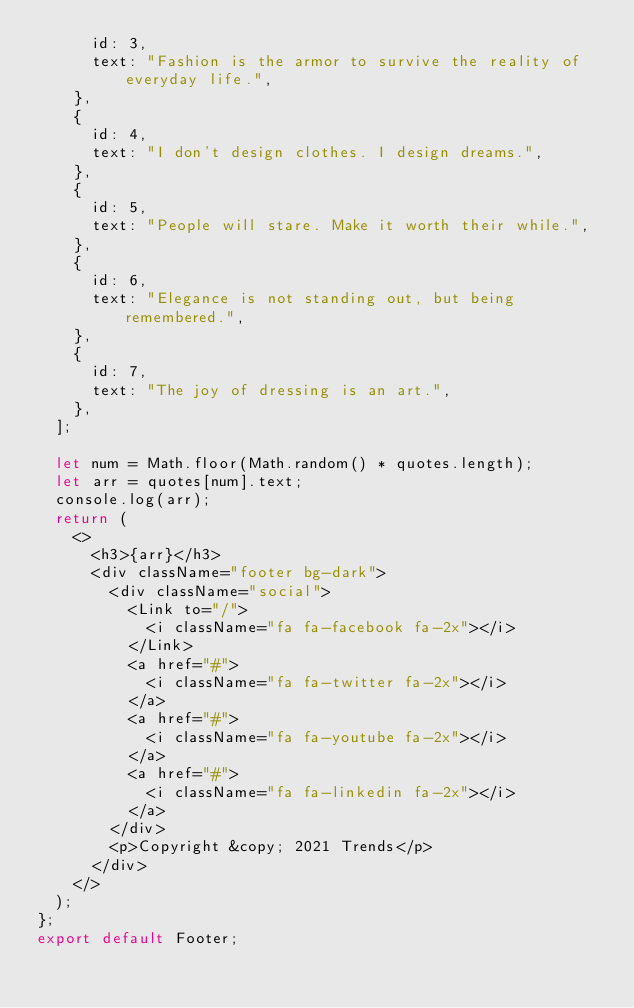<code> <loc_0><loc_0><loc_500><loc_500><_JavaScript_>      id: 3,
      text: "Fashion is the armor to survive the reality of everyday life.",
    },
    {
      id: 4,
      text: "I don't design clothes. I design dreams.",
    },
    {
      id: 5,
      text: "People will stare. Make it worth their while.",
    },
    {
      id: 6,
      text: "Elegance is not standing out, but being remembered.",
    },
    {
      id: 7,
      text: "The joy of dressing is an art.",
    },
  ];

  let num = Math.floor(Math.random() * quotes.length);
  let arr = quotes[num].text;
  console.log(arr);
  return (
    <>
      <h3>{arr}</h3>
      <div className="footer bg-dark">
        <div className="social">
          <Link to="/">
            <i className="fa fa-facebook fa-2x"></i>
          </Link>
          <a href="#">
            <i className="fa fa-twitter fa-2x"></i>
          </a>
          <a href="#">
            <i className="fa fa-youtube fa-2x"></i>
          </a>
          <a href="#">
            <i className="fa fa-linkedin fa-2x"></i>
          </a>
        </div>
        <p>Copyright &copy; 2021 Trends</p>
      </div>
    </>
  );
};
export default Footer;
</code> 